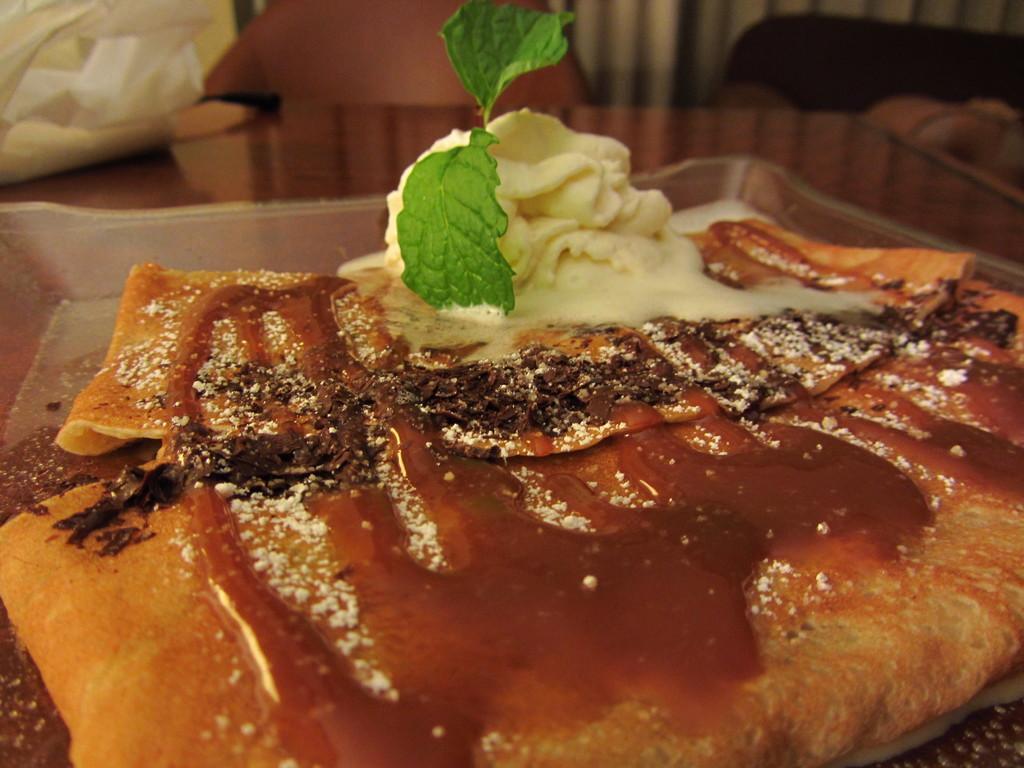Can you describe this image briefly? In this image there is a tray. In the tray there is some food. The tray is on the table. In the background there is a chair. Behind the chair there is a curtain. On the table there is a cover on the left side top corner. 